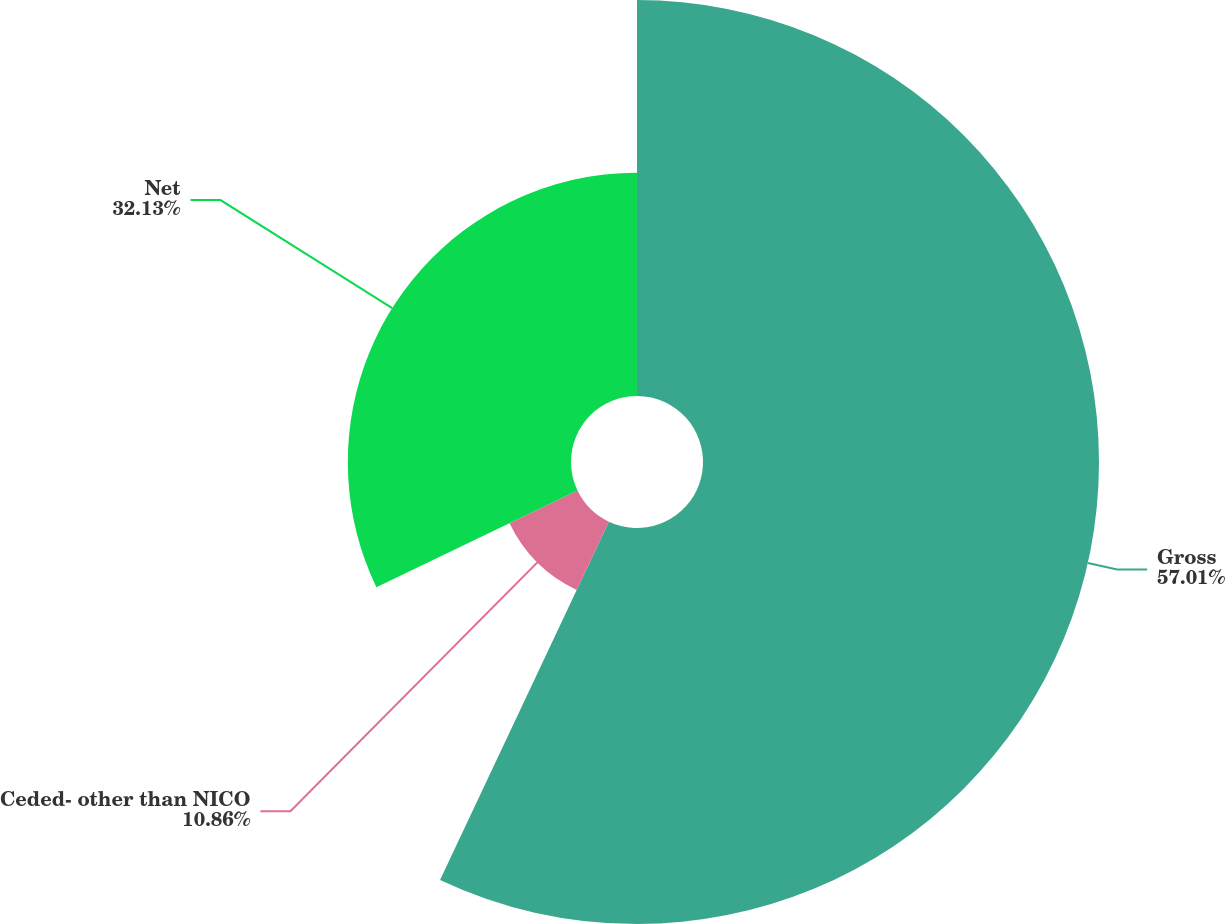Convert chart. <chart><loc_0><loc_0><loc_500><loc_500><pie_chart><fcel>Gross<fcel>Ceded- other than NICO<fcel>Net<nl><fcel>57.01%<fcel>10.86%<fcel>32.13%<nl></chart> 